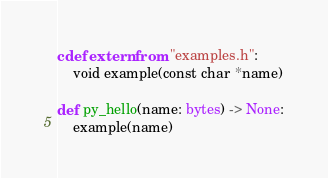Convert code to text. <code><loc_0><loc_0><loc_500><loc_500><_Cython_>cdef extern from "examples.h":
    void example(const char *name)

def py_hello(name: bytes) -> None:
    example(name)
</code> 